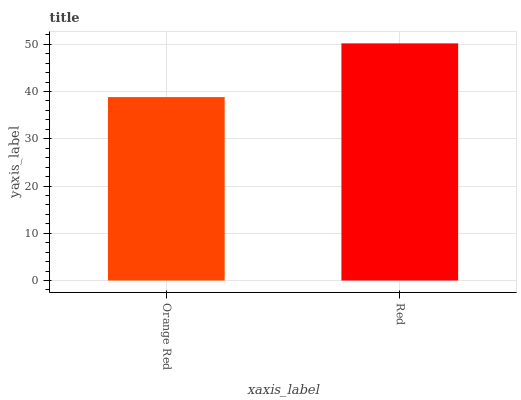Is Orange Red the minimum?
Answer yes or no. Yes. Is Red the maximum?
Answer yes or no. Yes. Is Red the minimum?
Answer yes or no. No. Is Red greater than Orange Red?
Answer yes or no. Yes. Is Orange Red less than Red?
Answer yes or no. Yes. Is Orange Red greater than Red?
Answer yes or no. No. Is Red less than Orange Red?
Answer yes or no. No. Is Red the high median?
Answer yes or no. Yes. Is Orange Red the low median?
Answer yes or no. Yes. Is Orange Red the high median?
Answer yes or no. No. Is Red the low median?
Answer yes or no. No. 